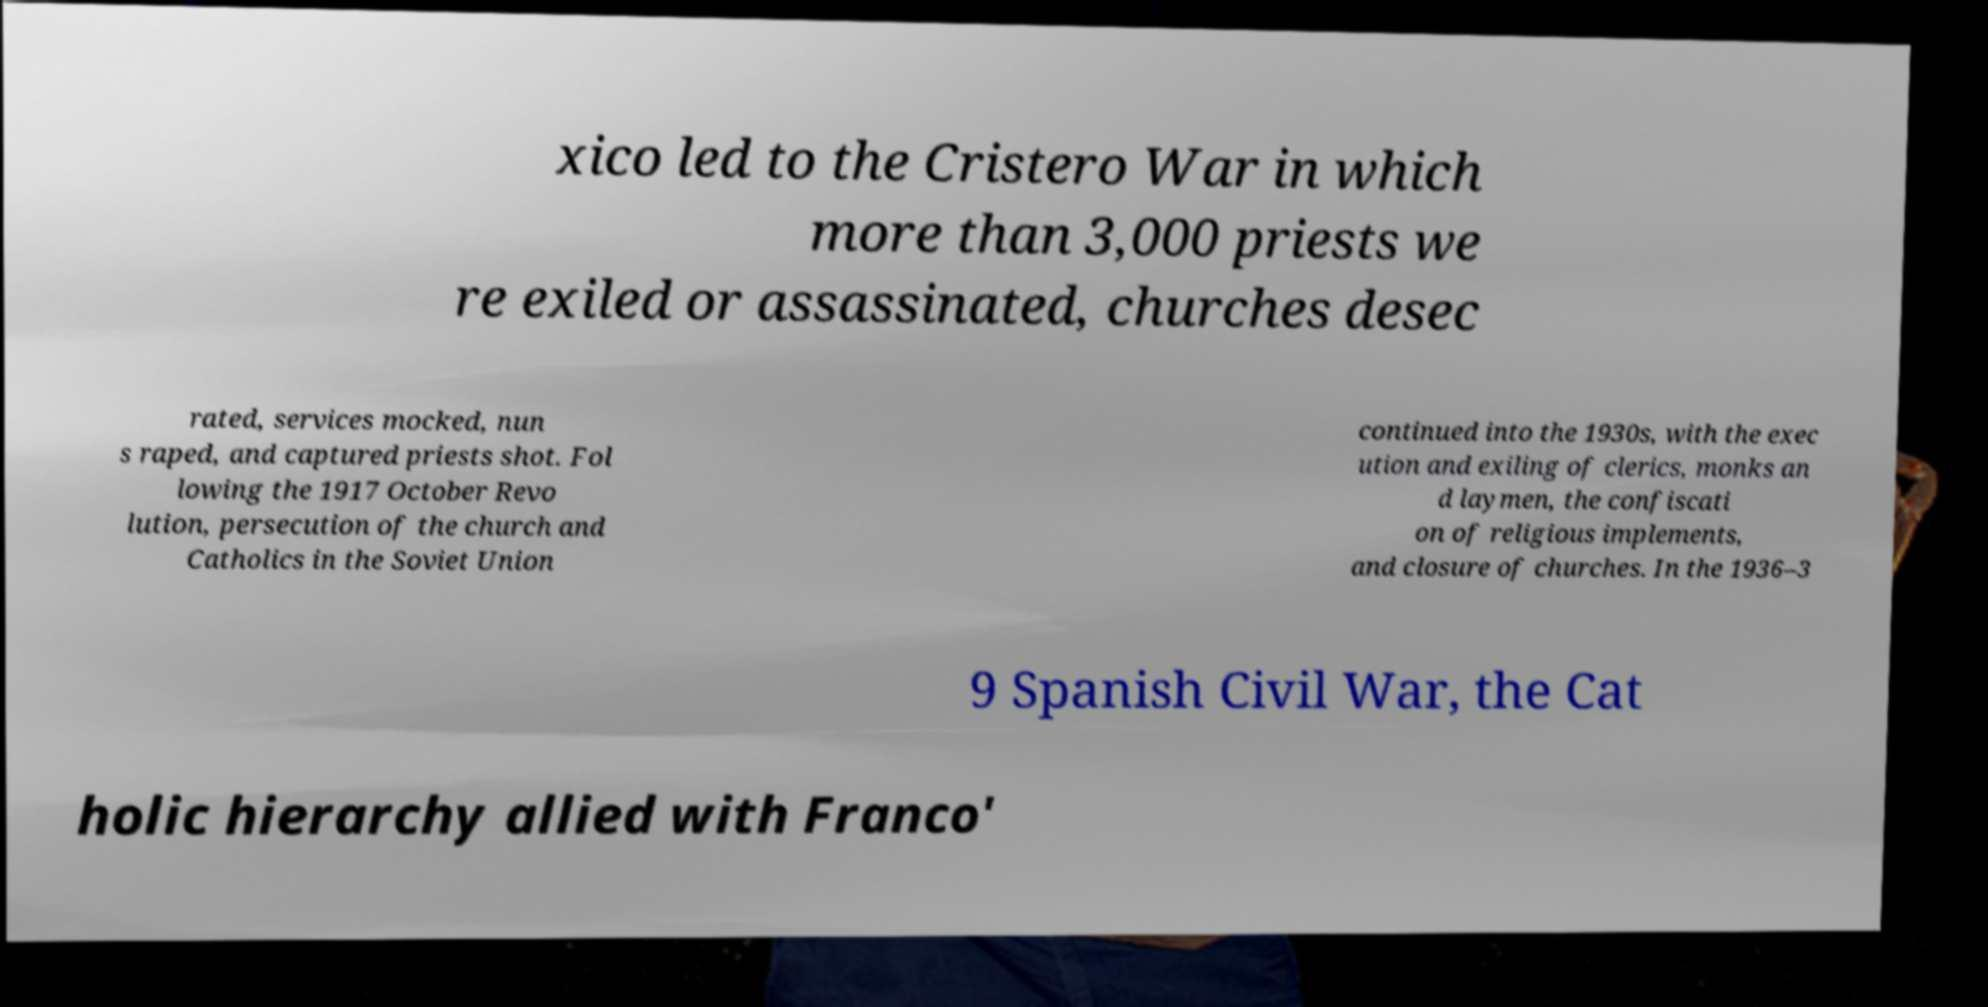There's text embedded in this image that I need extracted. Can you transcribe it verbatim? xico led to the Cristero War in which more than 3,000 priests we re exiled or assassinated, churches desec rated, services mocked, nun s raped, and captured priests shot. Fol lowing the 1917 October Revo lution, persecution of the church and Catholics in the Soviet Union continued into the 1930s, with the exec ution and exiling of clerics, monks an d laymen, the confiscati on of religious implements, and closure of churches. In the 1936–3 9 Spanish Civil War, the Cat holic hierarchy allied with Franco' 